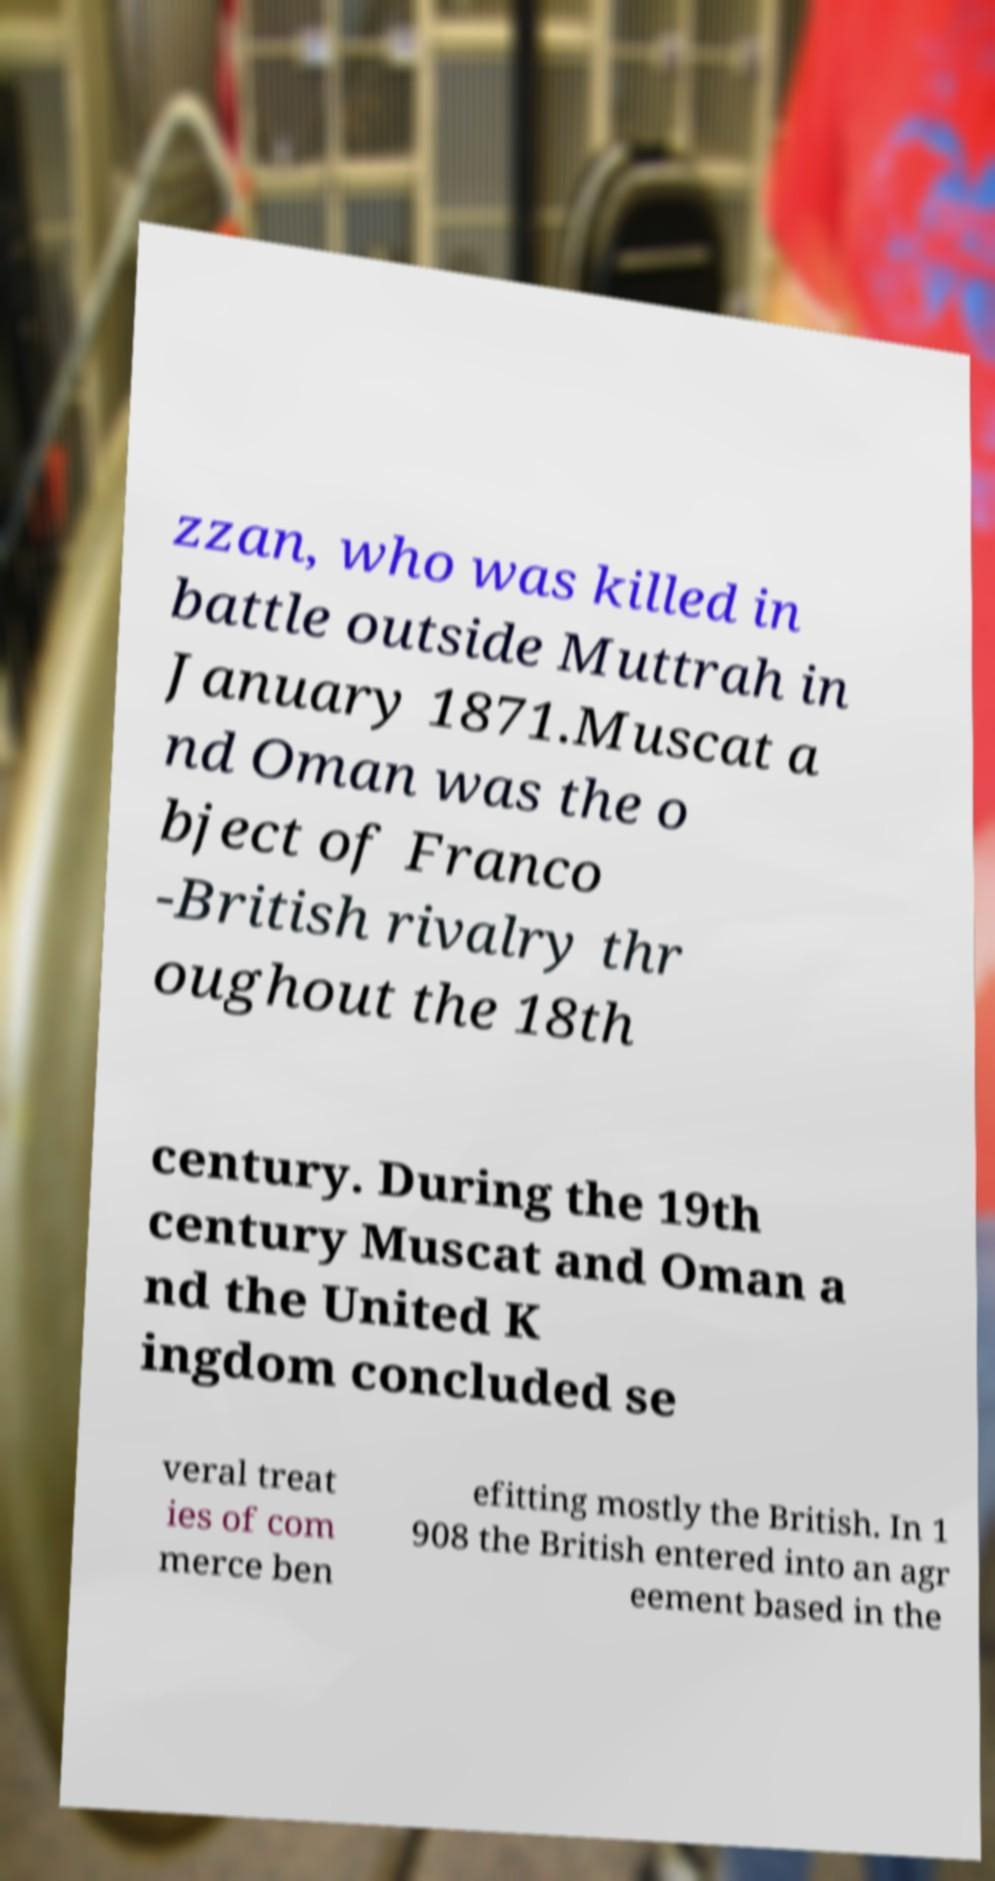Could you extract and type out the text from this image? zzan, who was killed in battle outside Muttrah in January 1871.Muscat a nd Oman was the o bject of Franco -British rivalry thr oughout the 18th century. During the 19th century Muscat and Oman a nd the United K ingdom concluded se veral treat ies of com merce ben efitting mostly the British. In 1 908 the British entered into an agr eement based in the 